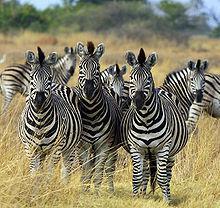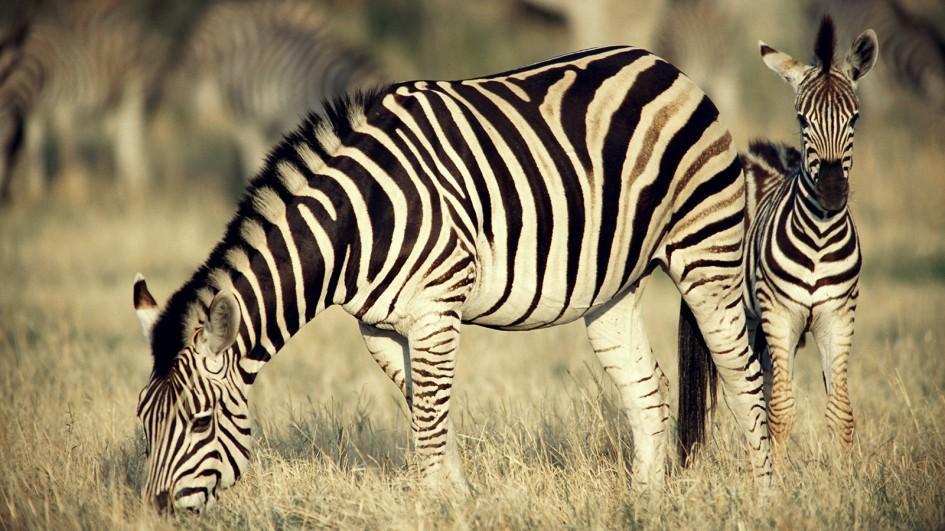The first image is the image on the left, the second image is the image on the right. Examine the images to the left and right. Is the description "There is a mother zebra standing in the grass with her baby close to her" accurate? Answer yes or no. Yes. The first image is the image on the left, the second image is the image on the right. For the images shown, is this caption "The right image contains only one zebra." true? Answer yes or no. No. 